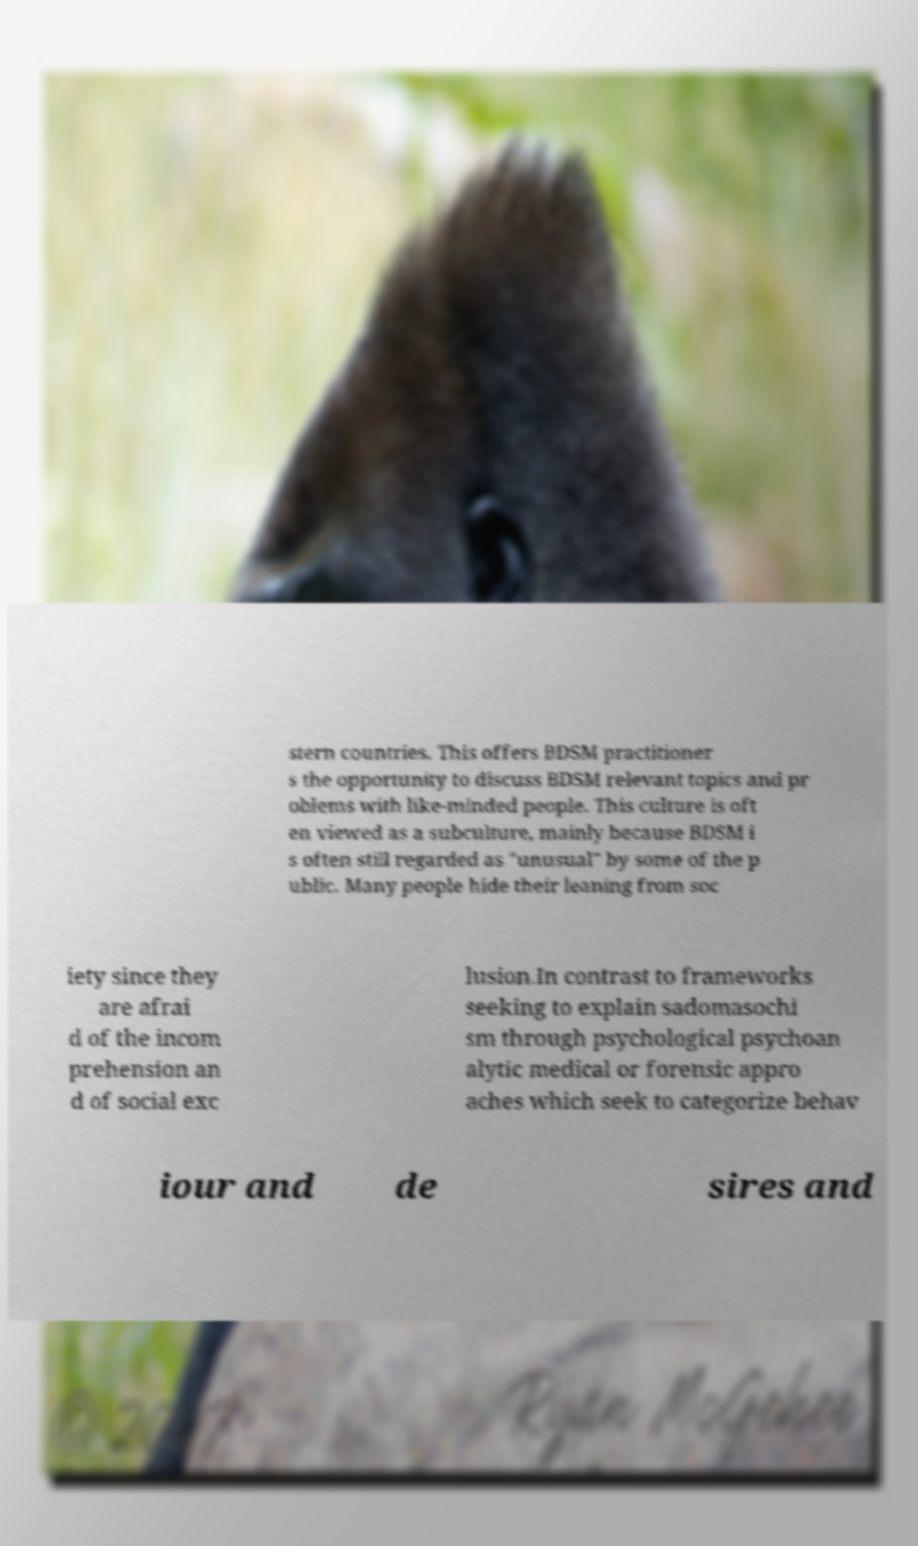I need the written content from this picture converted into text. Can you do that? stern countries. This offers BDSM practitioner s the opportunity to discuss BDSM relevant topics and pr oblems with like-minded people. This culture is oft en viewed as a subculture, mainly because BDSM i s often still regarded as "unusual" by some of the p ublic. Many people hide their leaning from soc iety since they are afrai d of the incom prehension an d of social exc lusion.In contrast to frameworks seeking to explain sadomasochi sm through psychological psychoan alytic medical or forensic appro aches which seek to categorize behav iour and de sires and 